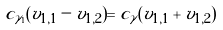Convert formula to latex. <formula><loc_0><loc_0><loc_500><loc_500>c _ { \gamma _ { 1 } } ( v _ { 1 , 1 } - v _ { 1 , 2 } ) = c _ { \tilde { \gamma } } ( v _ { 1 , 1 } + v _ { 1 , 2 } )</formula> 